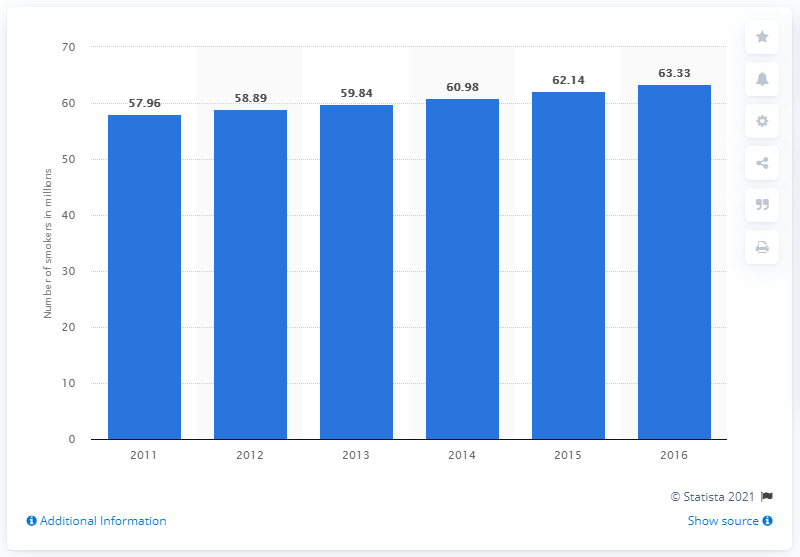Identify some key points in this picture. In 2016, it is estimated that approximately 63.33% of the population of Indonesia were smokers. 